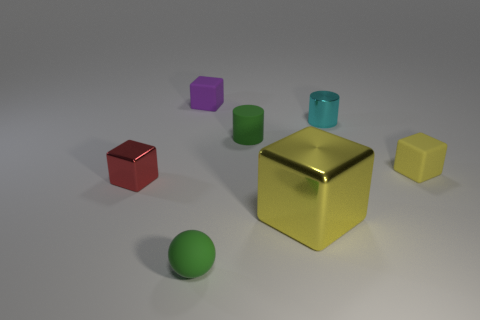What number of things are either big brown blocks or tiny blocks that are on the left side of the yellow shiny cube?
Give a very brief answer. 2. Does the cyan thing have the same size as the purple object?
Your response must be concise. Yes. Are there any yellow rubber blocks left of the purple object?
Ensure brevity in your answer.  No. What is the size of the thing that is behind the matte cylinder and right of the big yellow cube?
Ensure brevity in your answer.  Small. What number of things are either large red metal blocks or small rubber balls?
Give a very brief answer. 1. There is a rubber cylinder; is its size the same as the yellow metallic object to the right of the red shiny object?
Your response must be concise. No. What size is the shiny object left of the small cube behind the rubber cylinder that is on the right side of the purple block?
Ensure brevity in your answer.  Small. Are there any tiny yellow matte objects?
Your response must be concise. Yes. There is a small thing that is the same color as the tiny matte cylinder; what material is it?
Your answer should be very brief. Rubber. What number of big shiny blocks are the same color as the matte ball?
Make the answer very short. 0. 